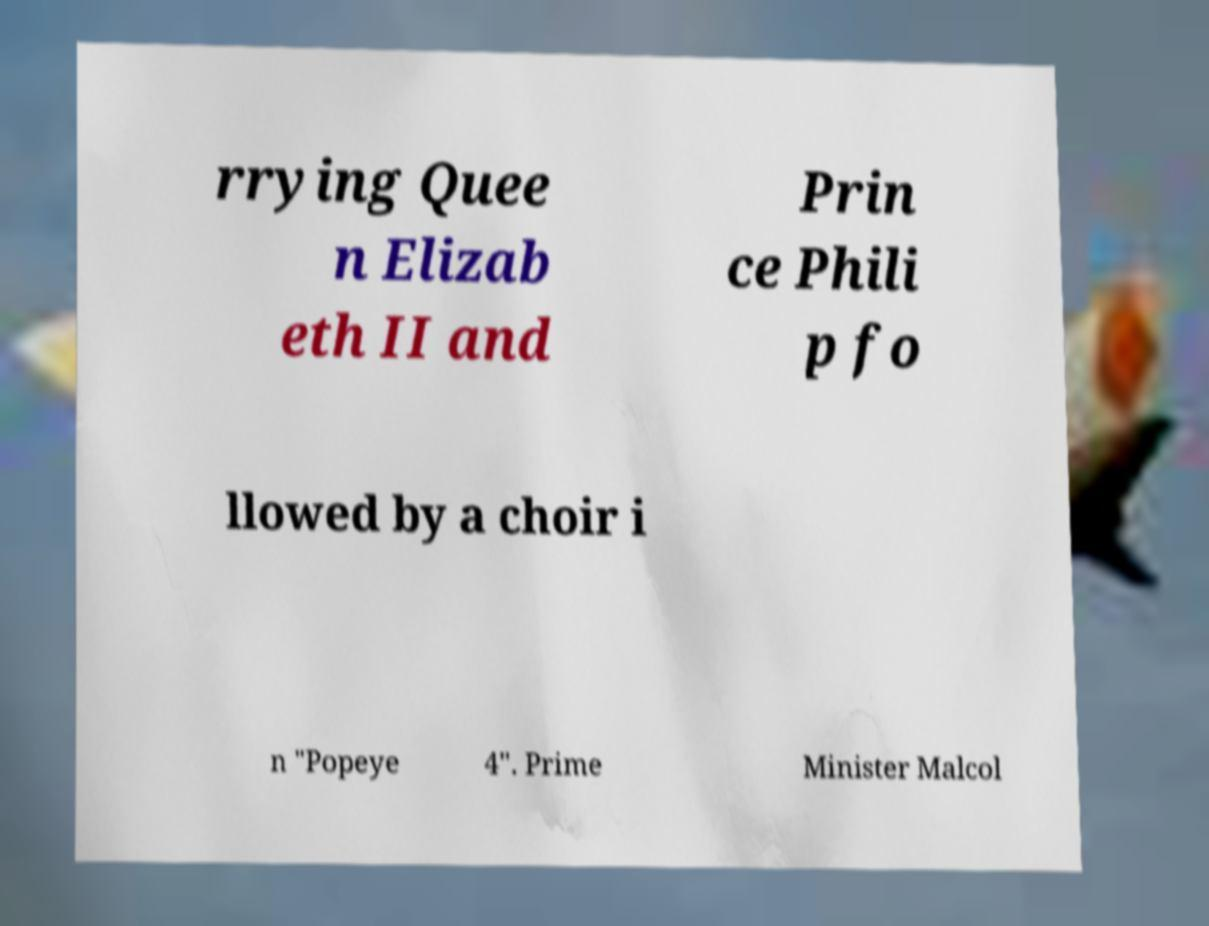There's text embedded in this image that I need extracted. Can you transcribe it verbatim? rrying Quee n Elizab eth II and Prin ce Phili p fo llowed by a choir i n "Popeye 4". Prime Minister Malcol 